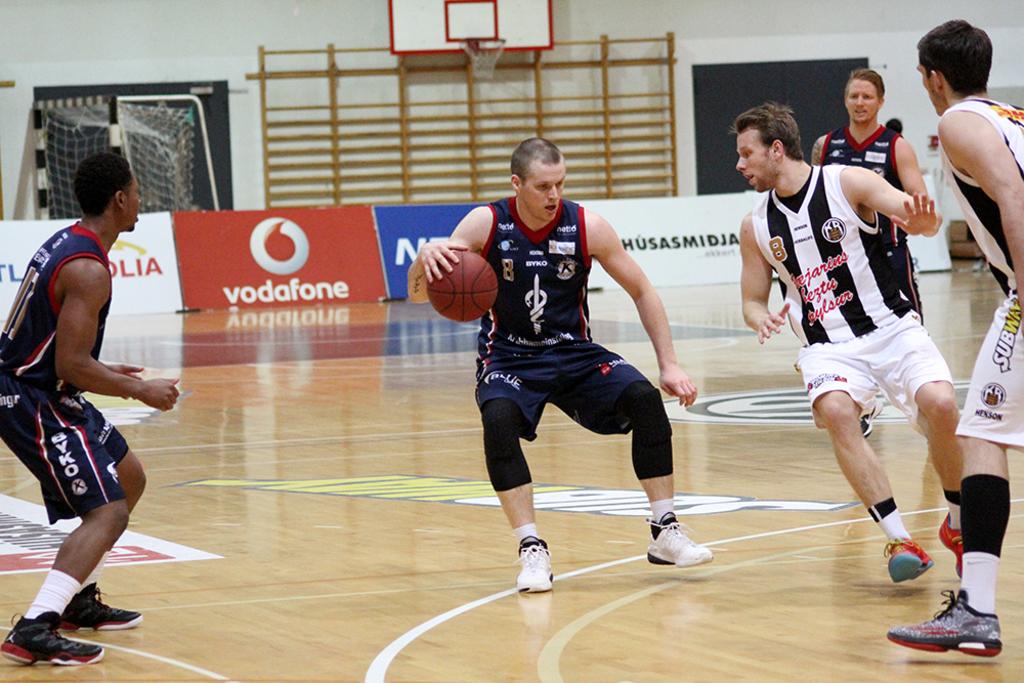Isn't that red sign a cell phone provider?
Provide a succinct answer. Yes. 